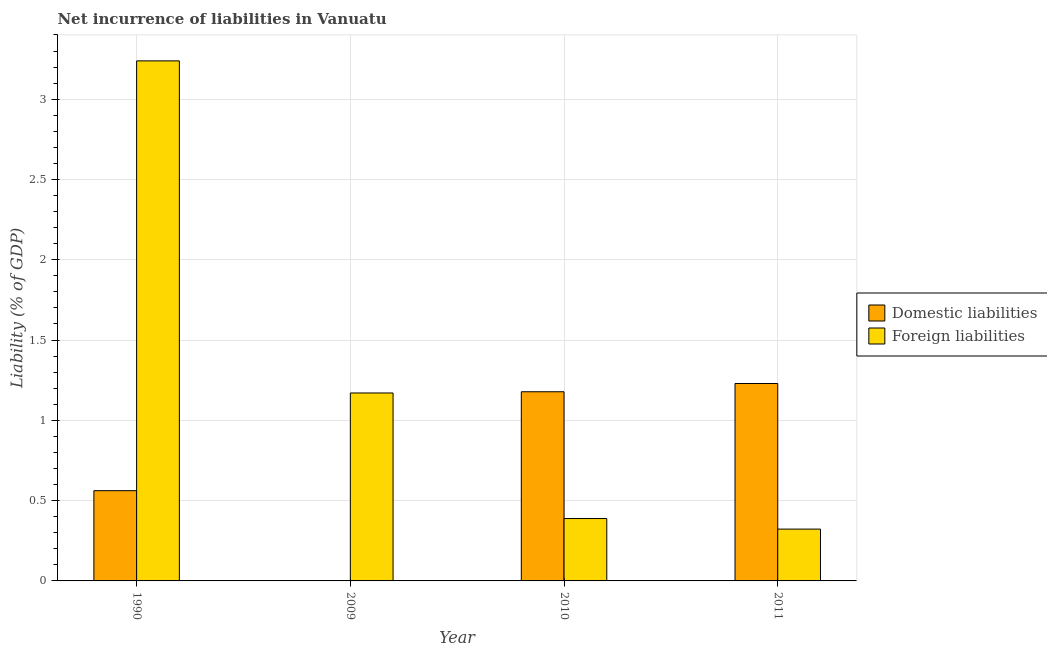How many different coloured bars are there?
Provide a succinct answer. 2. Are the number of bars per tick equal to the number of legend labels?
Keep it short and to the point. No. Are the number of bars on each tick of the X-axis equal?
Offer a very short reply. No. How many bars are there on the 2nd tick from the left?
Keep it short and to the point. 1. How many bars are there on the 2nd tick from the right?
Provide a succinct answer. 2. In how many cases, is the number of bars for a given year not equal to the number of legend labels?
Your answer should be very brief. 1. What is the incurrence of foreign liabilities in 1990?
Provide a short and direct response. 3.24. Across all years, what is the maximum incurrence of domestic liabilities?
Provide a succinct answer. 1.23. Across all years, what is the minimum incurrence of foreign liabilities?
Your answer should be compact. 0.32. What is the total incurrence of foreign liabilities in the graph?
Offer a terse response. 5.12. What is the difference between the incurrence of domestic liabilities in 1990 and that in 2011?
Give a very brief answer. -0.67. What is the difference between the incurrence of foreign liabilities in 1990 and the incurrence of domestic liabilities in 2010?
Keep it short and to the point. 2.85. What is the average incurrence of foreign liabilities per year?
Offer a very short reply. 1.28. In how many years, is the incurrence of foreign liabilities greater than 3.3 %?
Provide a short and direct response. 0. What is the ratio of the incurrence of foreign liabilities in 1990 to that in 2010?
Offer a terse response. 8.34. What is the difference between the highest and the second highest incurrence of domestic liabilities?
Your answer should be compact. 0.05. What is the difference between the highest and the lowest incurrence of domestic liabilities?
Keep it short and to the point. 1.23. Is the sum of the incurrence of domestic liabilities in 1990 and 2010 greater than the maximum incurrence of foreign liabilities across all years?
Offer a terse response. Yes. Are all the bars in the graph horizontal?
Keep it short and to the point. No. How many years are there in the graph?
Your response must be concise. 4. Does the graph contain any zero values?
Your answer should be very brief. Yes. Where does the legend appear in the graph?
Keep it short and to the point. Center right. How many legend labels are there?
Give a very brief answer. 2. What is the title of the graph?
Your answer should be very brief. Net incurrence of liabilities in Vanuatu. What is the label or title of the Y-axis?
Your answer should be very brief. Liability (% of GDP). What is the Liability (% of GDP) in Domestic liabilities in 1990?
Give a very brief answer. 0.56. What is the Liability (% of GDP) in Foreign liabilities in 1990?
Offer a terse response. 3.24. What is the Liability (% of GDP) in Foreign liabilities in 2009?
Ensure brevity in your answer.  1.17. What is the Liability (% of GDP) of Domestic liabilities in 2010?
Keep it short and to the point. 1.18. What is the Liability (% of GDP) in Foreign liabilities in 2010?
Offer a terse response. 0.39. What is the Liability (% of GDP) in Domestic liabilities in 2011?
Provide a succinct answer. 1.23. What is the Liability (% of GDP) of Foreign liabilities in 2011?
Give a very brief answer. 0.32. Across all years, what is the maximum Liability (% of GDP) of Domestic liabilities?
Your answer should be very brief. 1.23. Across all years, what is the maximum Liability (% of GDP) of Foreign liabilities?
Your answer should be compact. 3.24. Across all years, what is the minimum Liability (% of GDP) of Domestic liabilities?
Your answer should be very brief. 0. Across all years, what is the minimum Liability (% of GDP) of Foreign liabilities?
Provide a short and direct response. 0.32. What is the total Liability (% of GDP) of Domestic liabilities in the graph?
Provide a succinct answer. 2.97. What is the total Liability (% of GDP) in Foreign liabilities in the graph?
Provide a succinct answer. 5.12. What is the difference between the Liability (% of GDP) of Foreign liabilities in 1990 and that in 2009?
Keep it short and to the point. 2.07. What is the difference between the Liability (% of GDP) of Domestic liabilities in 1990 and that in 2010?
Offer a terse response. -0.62. What is the difference between the Liability (% of GDP) of Foreign liabilities in 1990 and that in 2010?
Make the answer very short. 2.85. What is the difference between the Liability (% of GDP) of Domestic liabilities in 1990 and that in 2011?
Provide a short and direct response. -0.67. What is the difference between the Liability (% of GDP) in Foreign liabilities in 1990 and that in 2011?
Ensure brevity in your answer.  2.92. What is the difference between the Liability (% of GDP) of Foreign liabilities in 2009 and that in 2010?
Provide a succinct answer. 0.78. What is the difference between the Liability (% of GDP) of Foreign liabilities in 2009 and that in 2011?
Give a very brief answer. 0.85. What is the difference between the Liability (% of GDP) of Domestic liabilities in 2010 and that in 2011?
Make the answer very short. -0.05. What is the difference between the Liability (% of GDP) of Foreign liabilities in 2010 and that in 2011?
Your response must be concise. 0.07. What is the difference between the Liability (% of GDP) of Domestic liabilities in 1990 and the Liability (% of GDP) of Foreign liabilities in 2009?
Your answer should be compact. -0.61. What is the difference between the Liability (% of GDP) of Domestic liabilities in 1990 and the Liability (% of GDP) of Foreign liabilities in 2010?
Your answer should be very brief. 0.17. What is the difference between the Liability (% of GDP) of Domestic liabilities in 1990 and the Liability (% of GDP) of Foreign liabilities in 2011?
Give a very brief answer. 0.24. What is the difference between the Liability (% of GDP) in Domestic liabilities in 2010 and the Liability (% of GDP) in Foreign liabilities in 2011?
Offer a terse response. 0.86. What is the average Liability (% of GDP) of Domestic liabilities per year?
Keep it short and to the point. 0.74. What is the average Liability (% of GDP) of Foreign liabilities per year?
Your response must be concise. 1.28. In the year 1990, what is the difference between the Liability (% of GDP) of Domestic liabilities and Liability (% of GDP) of Foreign liabilities?
Ensure brevity in your answer.  -2.68. In the year 2010, what is the difference between the Liability (% of GDP) of Domestic liabilities and Liability (% of GDP) of Foreign liabilities?
Keep it short and to the point. 0.79. In the year 2011, what is the difference between the Liability (% of GDP) of Domestic liabilities and Liability (% of GDP) of Foreign liabilities?
Keep it short and to the point. 0.91. What is the ratio of the Liability (% of GDP) of Foreign liabilities in 1990 to that in 2009?
Offer a very short reply. 2.77. What is the ratio of the Liability (% of GDP) of Domestic liabilities in 1990 to that in 2010?
Keep it short and to the point. 0.48. What is the ratio of the Liability (% of GDP) of Foreign liabilities in 1990 to that in 2010?
Ensure brevity in your answer.  8.34. What is the ratio of the Liability (% of GDP) in Domestic liabilities in 1990 to that in 2011?
Give a very brief answer. 0.46. What is the ratio of the Liability (% of GDP) of Foreign liabilities in 1990 to that in 2011?
Ensure brevity in your answer.  10.04. What is the ratio of the Liability (% of GDP) of Foreign liabilities in 2009 to that in 2010?
Your answer should be very brief. 3.01. What is the ratio of the Liability (% of GDP) of Foreign liabilities in 2009 to that in 2011?
Your answer should be compact. 3.63. What is the ratio of the Liability (% of GDP) in Domestic liabilities in 2010 to that in 2011?
Your answer should be compact. 0.96. What is the ratio of the Liability (% of GDP) of Foreign liabilities in 2010 to that in 2011?
Keep it short and to the point. 1.2. What is the difference between the highest and the second highest Liability (% of GDP) in Domestic liabilities?
Keep it short and to the point. 0.05. What is the difference between the highest and the second highest Liability (% of GDP) in Foreign liabilities?
Provide a succinct answer. 2.07. What is the difference between the highest and the lowest Liability (% of GDP) of Domestic liabilities?
Keep it short and to the point. 1.23. What is the difference between the highest and the lowest Liability (% of GDP) in Foreign liabilities?
Offer a very short reply. 2.92. 